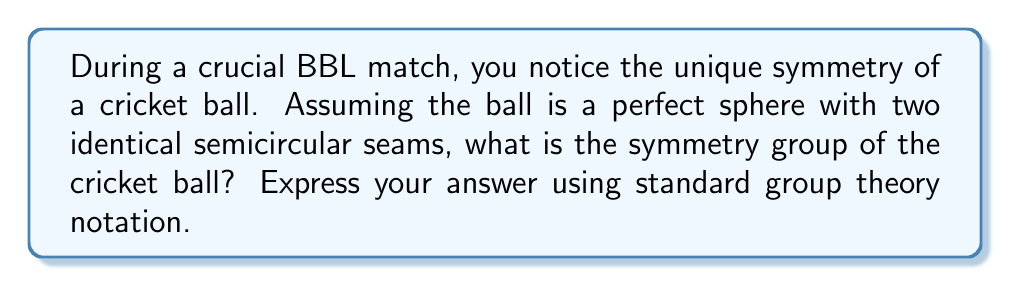Solve this math problem. To determine the symmetry group of a cricket ball, we need to consider its shape and the symmetries it possesses. Let's break this down step-by-step:

1. Shape: A cricket ball is essentially a sphere with two identical semicircular seams that divide it into four equal parts.

2. Rotational symmetries:
   a) The ball has infinite rotational symmetry around the axis perpendicular to the plane of the seams. This is represented by the group $SO(2)$.
   b) There are two 180° rotations around axes in the plane of the seams, perpendicular to each other.

3. Reflection symmetries:
   a) There is a reflection in the plane of the seams.
   b) There are two reflections in planes perpendicular to the seam plane, along the axes of the 180° rotations.

4. The symmetry group is a combination of these rotations and reflections. It's isomorphic to the direct product of $SO(2)$ and the dihedral group $D_2$.

5. In group theory notation, we represent this as:

   $$G \cong SO(2) \times D_2$$

   Where $\times$ denotes the direct product of groups.

6. The order of this group is infinite due to the $SO(2)$ component, which represents the infinite rotational symmetry around the axis perpendicular to the seam plane.

This symmetry group captures all the possible ways to rotate and reflect the cricket ball while maintaining its appearance, taking into account the sphere shape and the seam pattern.
Answer: $SO(2) \times D_2$ 